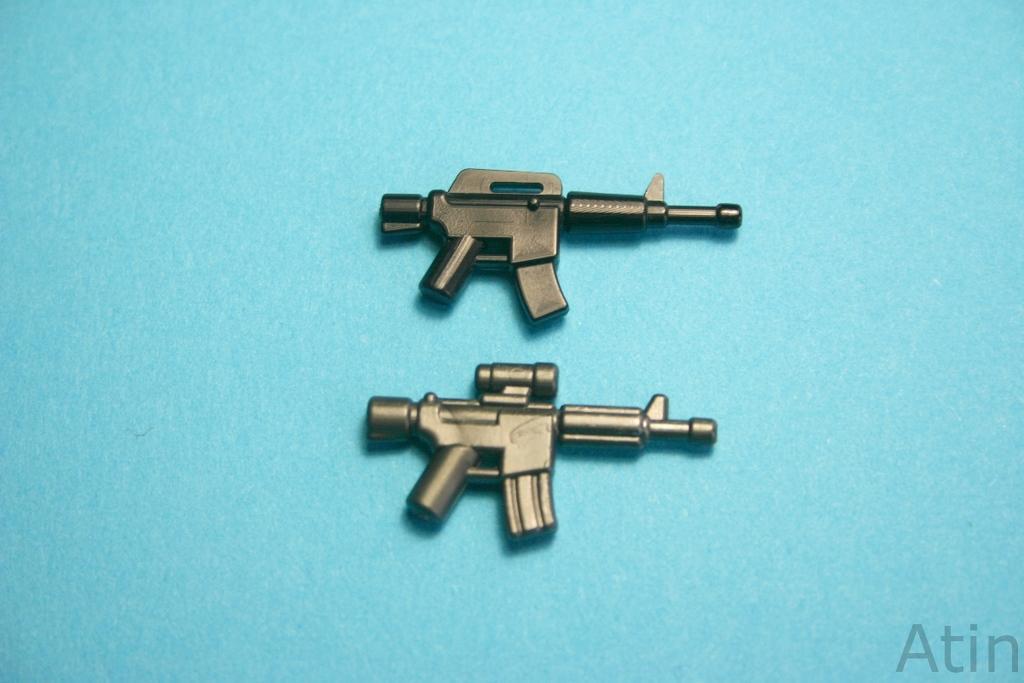Can you describe this image briefly? In this image I can see two toy guns, they are in black color and background is in blue color. 